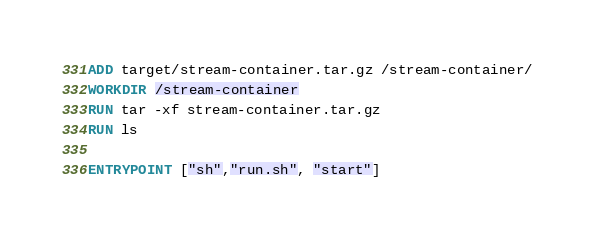Convert code to text. <code><loc_0><loc_0><loc_500><loc_500><_Dockerfile_>ADD target/stream-container.tar.gz /stream-container/
WORKDIR /stream-container
RUN tar -xf stream-container.tar.gz
RUN ls

ENTRYPOINT ["sh","run.sh", "start"]
</code> 